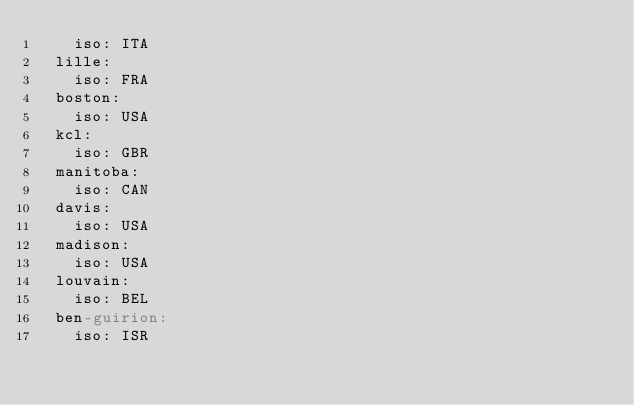Convert code to text. <code><loc_0><loc_0><loc_500><loc_500><_YAML_>    iso: ITA
  lille:
    iso: FRA
  boston:
    iso: USA
  kcl:
    iso: GBR
  manitoba:
    iso: CAN
  davis:
    iso: USA
  madison:
    iso: USA
  louvain:
    iso: BEL
  ben-guirion:
    iso: ISR
</code> 